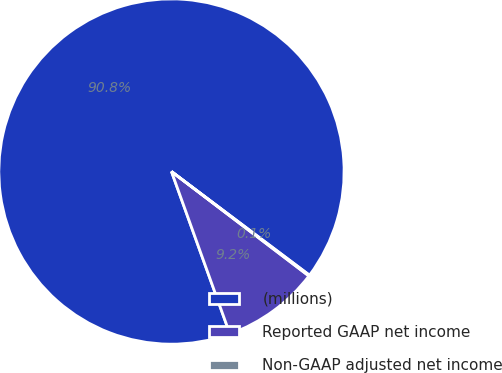Convert chart. <chart><loc_0><loc_0><loc_500><loc_500><pie_chart><fcel>(millions)<fcel>Reported GAAP net income<fcel>Non-GAAP adjusted net income<nl><fcel>90.75%<fcel>9.16%<fcel>0.09%<nl></chart> 